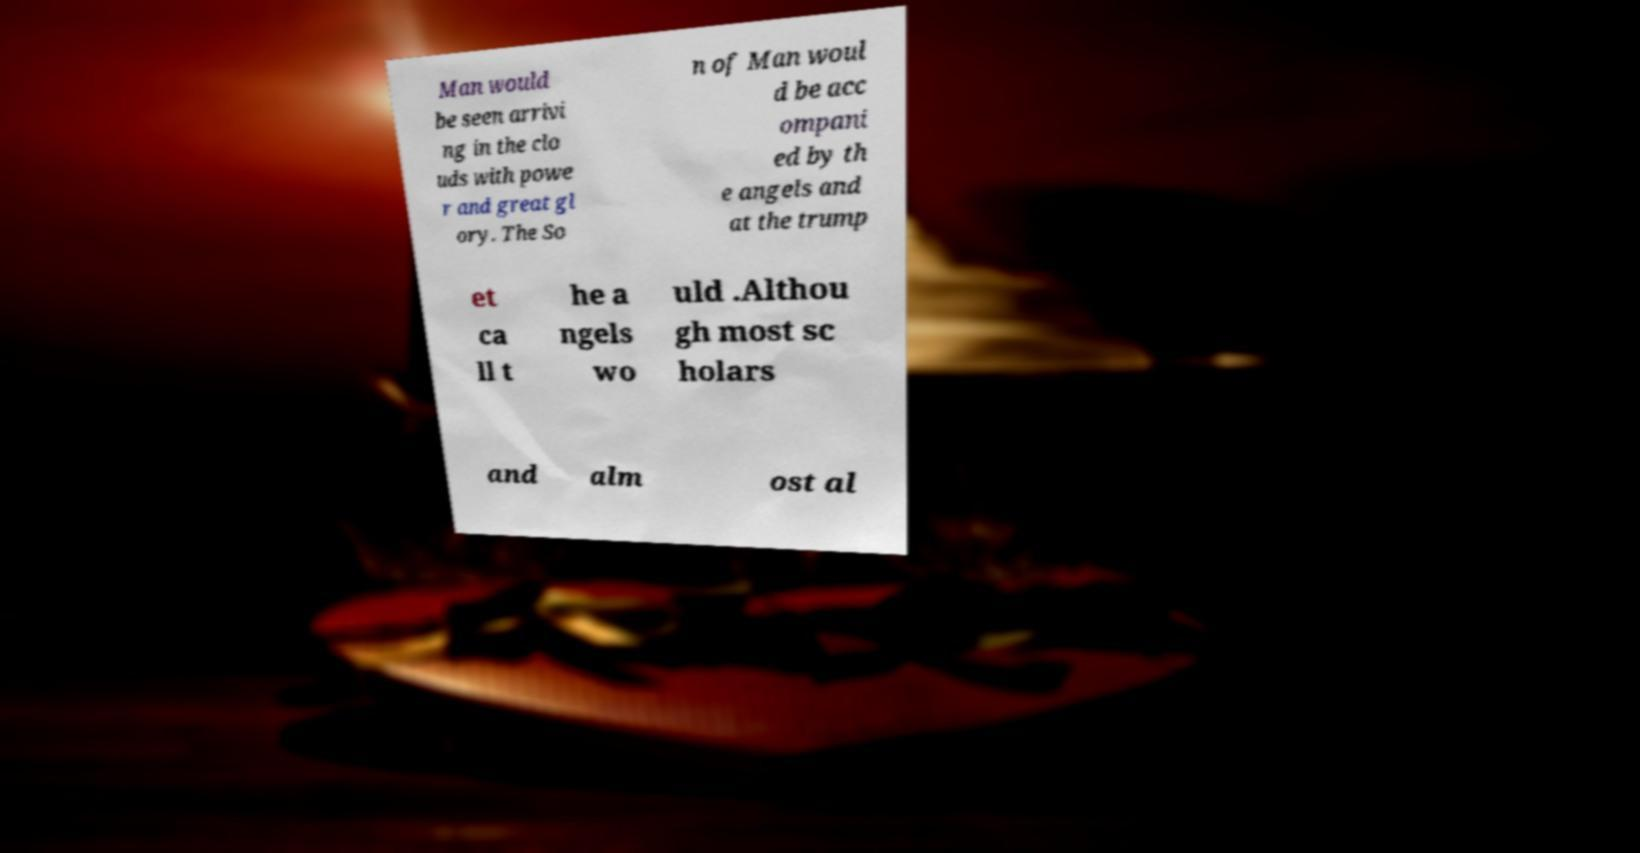There's text embedded in this image that I need extracted. Can you transcribe it verbatim? Man would be seen arrivi ng in the clo uds with powe r and great gl ory. The So n of Man woul d be acc ompani ed by th e angels and at the trump et ca ll t he a ngels wo uld .Althou gh most sc holars and alm ost al 